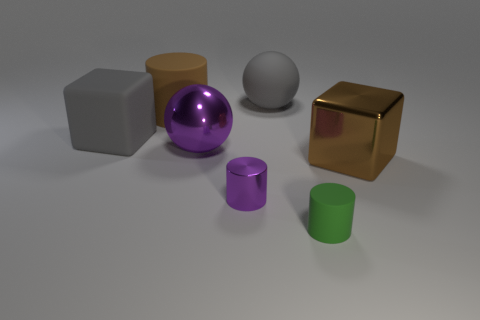Add 3 small blue cylinders. How many objects exist? 10 Subtract all tiny purple metallic cylinders. How many cylinders are left? 2 Subtract all spheres. How many objects are left? 5 Add 3 tiny cylinders. How many tiny cylinders are left? 5 Add 2 brown blocks. How many brown blocks exist? 3 Subtract all gray cubes. How many cubes are left? 1 Subtract 1 purple balls. How many objects are left? 6 Subtract 1 spheres. How many spheres are left? 1 Subtract all gray cylinders. Subtract all cyan blocks. How many cylinders are left? 3 Subtract all red cylinders. How many red spheres are left? 0 